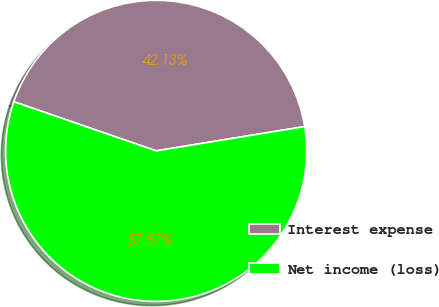Convert chart to OTSL. <chart><loc_0><loc_0><loc_500><loc_500><pie_chart><fcel>Interest expense<fcel>Net income (loss)<nl><fcel>42.13%<fcel>57.87%<nl></chart> 